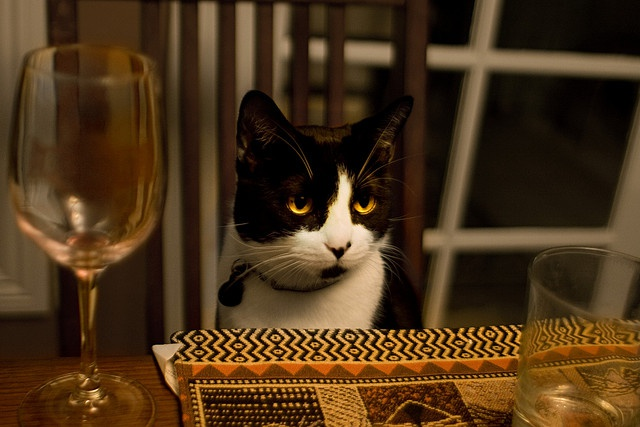Describe the objects in this image and their specific colors. I can see chair in gray and black tones, dining table in gray, maroon, olive, and black tones, cat in gray, black, olive, and tan tones, wine glass in gray, maroon, black, and olive tones, and cup in gray, olive, maroon, and black tones in this image. 